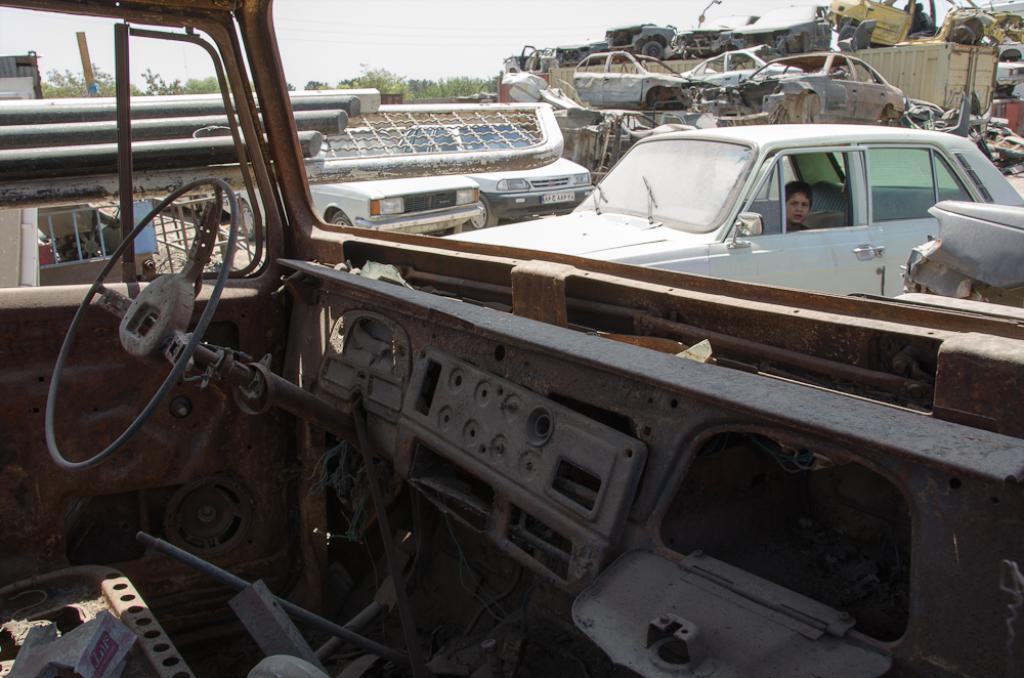Describe this image in one or two sentences. In this image in the front there is scrap. In the center there is a car and in the car there is a boy sitting. In the background there are cars, there are scraps and trees. 